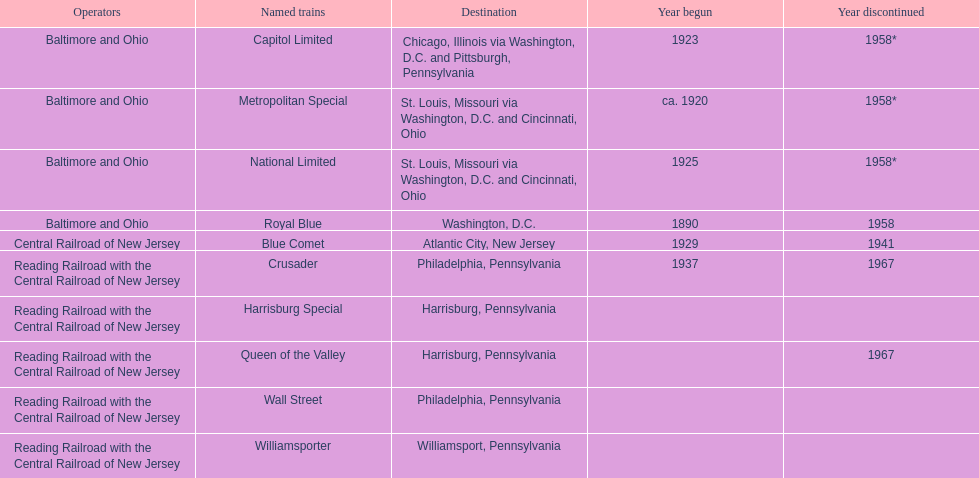What is the number one destination on the list? Chicago, Illinois via Washington, D.C. and Pittsburgh, Pennsylvania. 